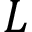Convert formula to latex. <formula><loc_0><loc_0><loc_500><loc_500>L</formula> 